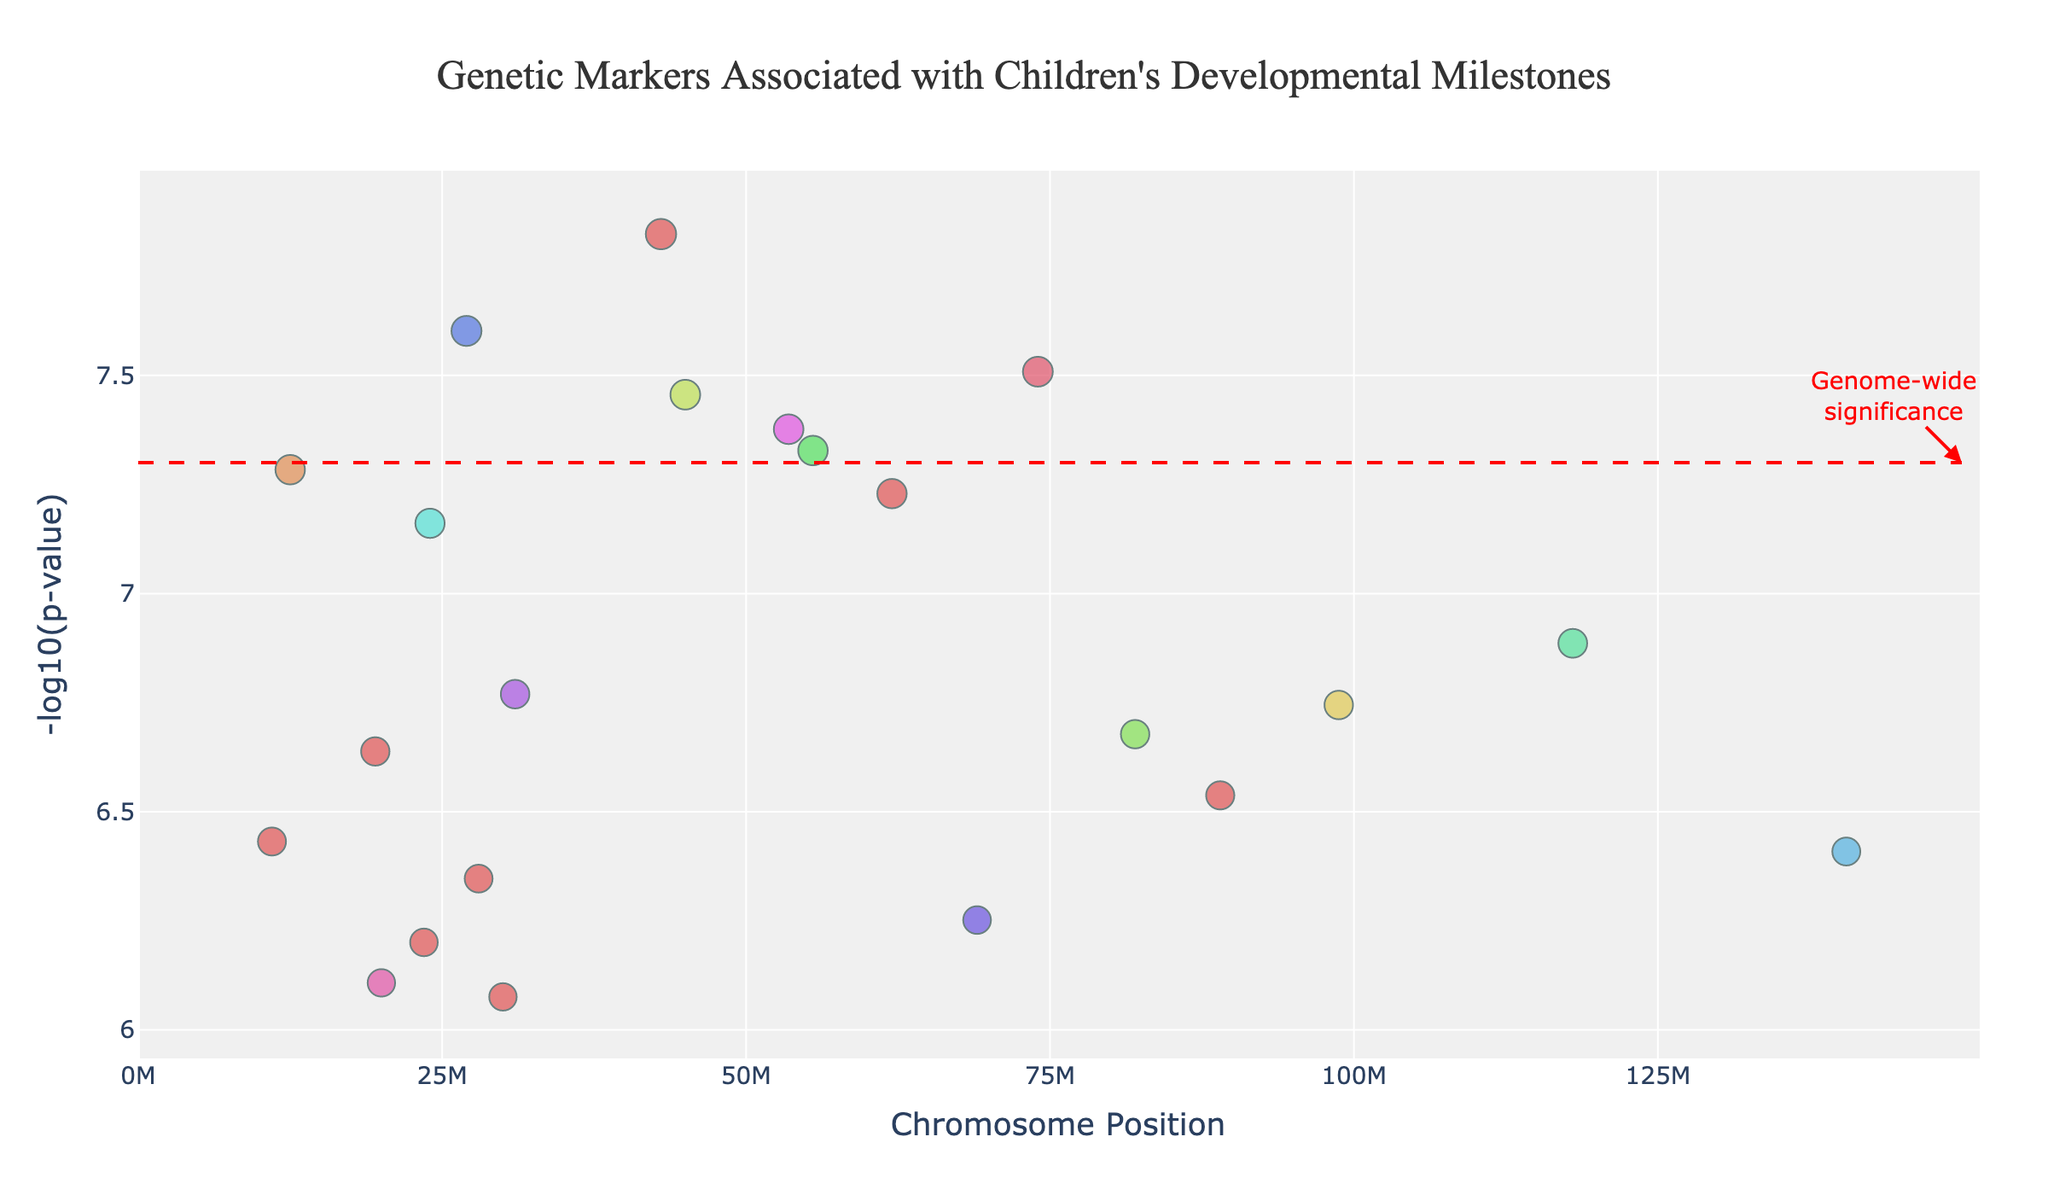What is the title of the plot? The title is located at the top of the plot and reads "Genetic Markers Associated with Children's Developmental Milestones".
Answer: Genetic Markers Associated with Children's Developmental Milestones Which chromosome has the marker with the smallest P-value? The smallest P-value corresponds to the highest -log10(p-value). From the plot, this marker is for chromosome 17 (SYNGAP1) with a -log10(p-value) higher than others.
Answer: Chromosome 17 What is the meaning of the red dashed line in the plot? The red dashed line represents the genome-wide significance threshold, which is marked at -log10(p-value) = 7.3. This indicates the level of statistical significance necessary for a genetic marker to be considered significant genome-wide.
Answer: Genome-wide significance threshold Which developmental milestone is associated with the gene FOXP2? The gene FOXP2 and its associated milestone can be identified by hovering over or looking at the data point on chromosome 3. The milestone associated with FOXP2 is "Language Development".
Answer: Language Development Compare the significance levels of the genes related to "Walking" and "First Words". Which one is more significant? The P-value associated with "Walking" is 1.8e-7 (-log10(p-value) = 6.74), while for "First Words" it is 5.2e-8 (-log10(p-value) = 7.28). Comparing these, the gene for "First Words" (NRXN1) is more significant as it has a higher -log10(p-value).
Answer: First Words How many markers exceed the genome-wide significance threshold? Markers exceeding the genome-wide significance threshold have -log10(p-value) values above 7.3. From the plot, there are markers for "First Words", "Language Development", "Fine Motor Skills", "Head Control", and "Self-Recognition" surpassing this level. Hence, there are 5 markers that exceed the threshold.
Answer: 5 markers What is the chromosome position of the gene associated with "Social Smiling"? By referring to the plot or associated data, the gene SHANK3, which is linked to "Social Smiling", is located at position 82000000 on chromosome 4.
Answer: 82000000 Which two developmental milestones have the closest significance levels? By comparing the -log10(p-values), "Symbolic Play" (CHRNA7, -log10(p-value) = 6.20) and "Toilet Training" (PRKCB, -log10(p-value) = 6.43) have very close significance levels, as their values are close numerically and visually on the plot.
Answer: Symbolic Play and Toilet Training What is the range of chromosome positions displayed in the plot? The x-axis represents chromosome positions, which range from 0 to approximately 150 million. This can be deduced from the axis ticks and labels in the plot.
Answer: 0 to 150 million 